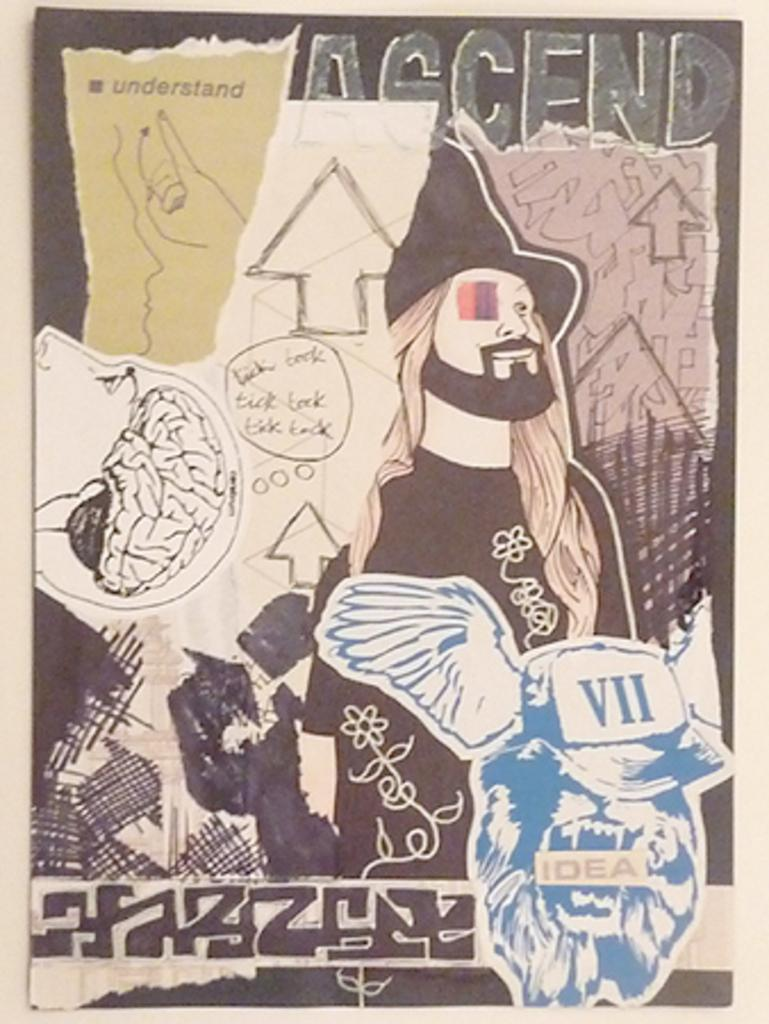What is on the board in the image? There is a poster on a board in the image. What type of images are on the poster? The poster contains cartoon pictures. What color is the powder that is falling during the rainstorm in the image? There is no rainstorm or powder present in the image; it only features a poster with cartoon pictures on a board. 